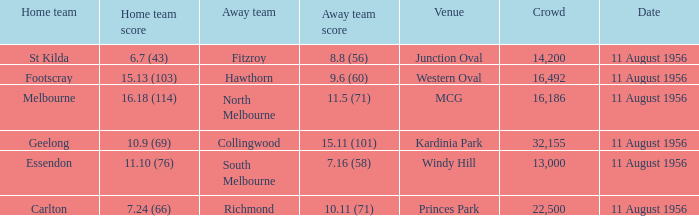Can you parse all the data within this table? {'header': ['Home team', 'Home team score', 'Away team', 'Away team score', 'Venue', 'Crowd', 'Date'], 'rows': [['St Kilda', '6.7 (43)', 'Fitzroy', '8.8 (56)', 'Junction Oval', '14,200', '11 August 1956'], ['Footscray', '15.13 (103)', 'Hawthorn', '9.6 (60)', 'Western Oval', '16,492', '11 August 1956'], ['Melbourne', '16.18 (114)', 'North Melbourne', '11.5 (71)', 'MCG', '16,186', '11 August 1956'], ['Geelong', '10.9 (69)', 'Collingwood', '15.11 (101)', 'Kardinia Park', '32,155', '11 August 1956'], ['Essendon', '11.10 (76)', 'South Melbourne', '7.16 (58)', 'Windy Hill', '13,000', '11 August 1956'], ['Carlton', '7.24 (66)', 'Richmond', '10.11 (71)', 'Princes Park', '22,500', '11 August 1956']]} What is the home team score for Footscray? 15.13 (103). 